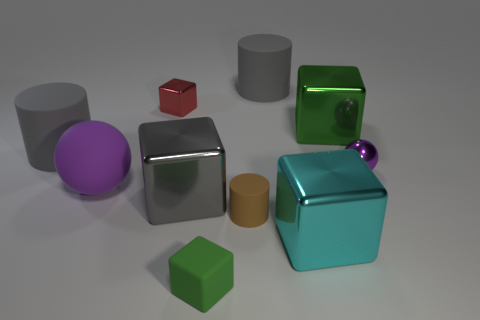Subtract 1 blocks. How many blocks are left? 4 Subtract all small metal blocks. How many blocks are left? 4 Subtract all red cylinders. Subtract all brown spheres. How many cylinders are left? 3 Subtract all cylinders. How many objects are left? 7 Add 8 red objects. How many red objects exist? 9 Subtract 1 brown cylinders. How many objects are left? 9 Subtract all big objects. Subtract all cyan metal blocks. How many objects are left? 3 Add 4 green objects. How many green objects are left? 6 